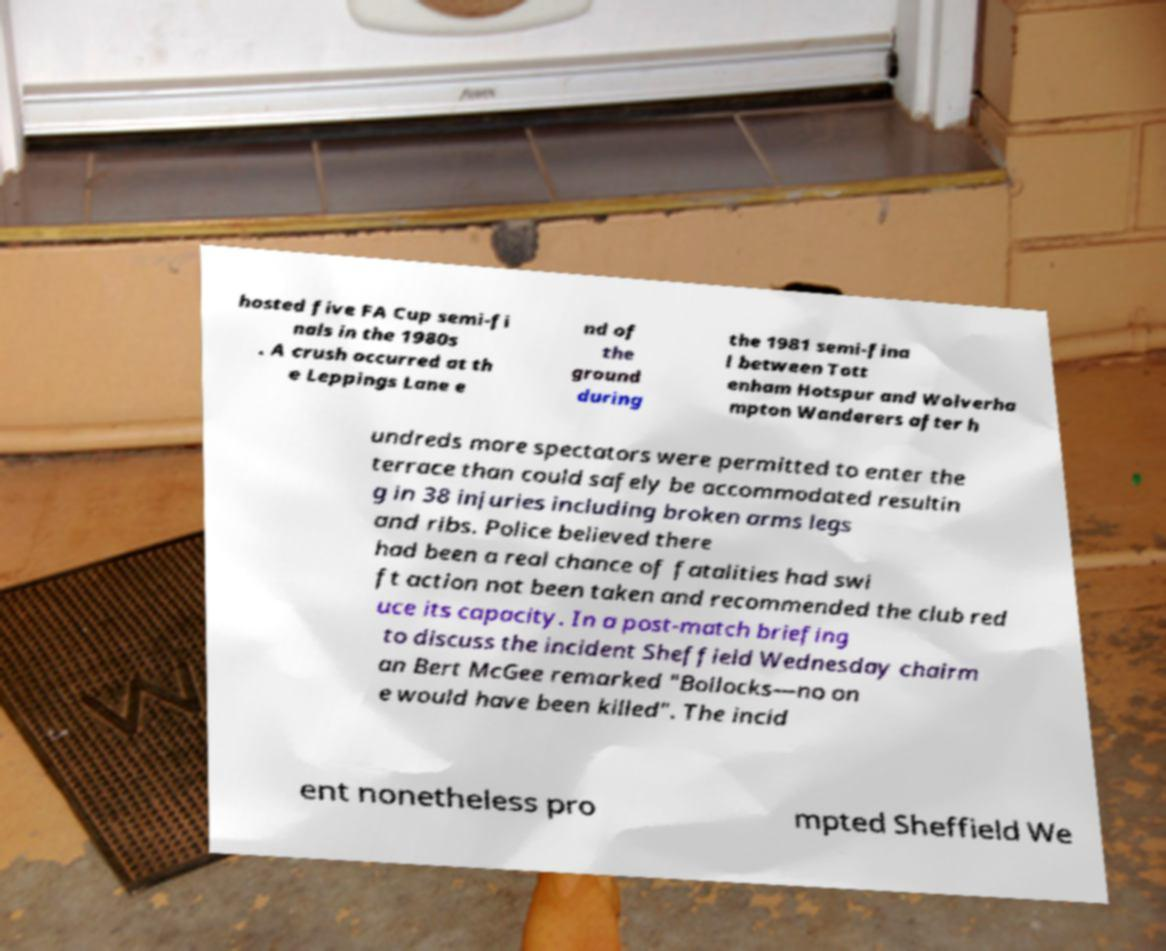Please identify and transcribe the text found in this image. hosted five FA Cup semi-fi nals in the 1980s . A crush occurred at th e Leppings Lane e nd of the ground during the 1981 semi-fina l between Tott enham Hotspur and Wolverha mpton Wanderers after h undreds more spectators were permitted to enter the terrace than could safely be accommodated resultin g in 38 injuries including broken arms legs and ribs. Police believed there had been a real chance of fatalities had swi ft action not been taken and recommended the club red uce its capacity. In a post-match briefing to discuss the incident Sheffield Wednesday chairm an Bert McGee remarked "Bollocks—no on e would have been killed". The incid ent nonetheless pro mpted Sheffield We 